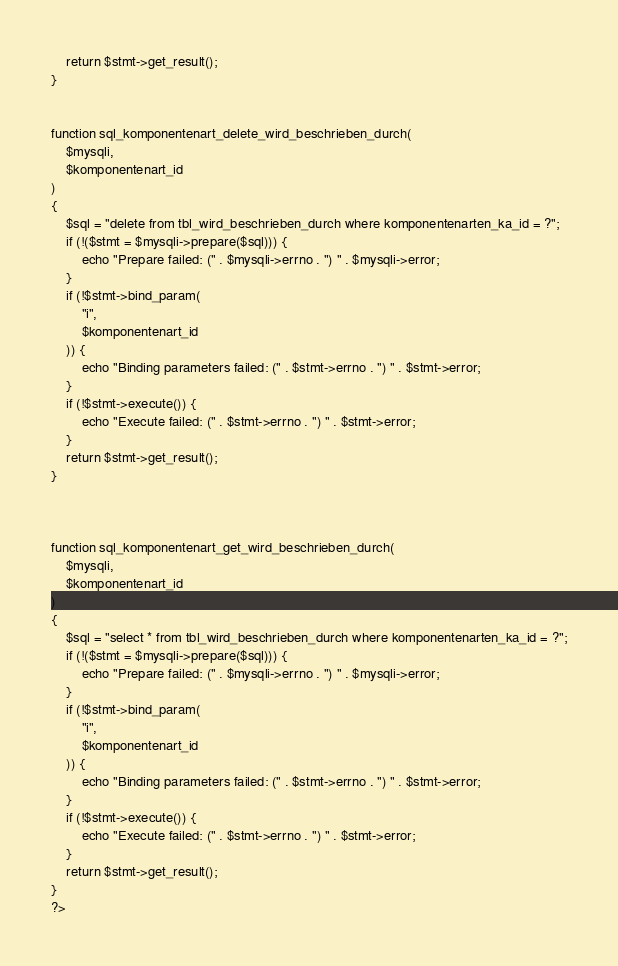Convert code to text. <code><loc_0><loc_0><loc_500><loc_500><_PHP_>    return $stmt->get_result();
}


function sql_komponentenart_delete_wird_beschrieben_durch(
    $mysqli,
    $komponentenart_id
)
{
    $sql = "delete from tbl_wird_beschrieben_durch where komponentenarten_ka_id = ?";
    if (!($stmt = $mysqli->prepare($sql))) {
        echo "Prepare failed: (" . $mysqli->errno . ") " . $mysqli->error;
    }
    if (!$stmt->bind_param(
        "i",
        $komponentenart_id
    )) {
        echo "Binding parameters failed: (" . $stmt->errno . ") " . $stmt->error;
    }
    if (!$stmt->execute()) {
        echo "Execute failed: (" . $stmt->errno . ") " . $stmt->error;
    }
    return $stmt->get_result();
}



function sql_komponentenart_get_wird_beschrieben_durch(
    $mysqli,
    $komponentenart_id
)
{
    $sql = "select * from tbl_wird_beschrieben_durch where komponentenarten_ka_id = ?";
    if (!($stmt = $mysqli->prepare($sql))) {
        echo "Prepare failed: (" . $mysqli->errno . ") " . $mysqli->error;
    }
    if (!$stmt->bind_param(
        "i",
        $komponentenart_id
    )) {
        echo "Binding parameters failed: (" . $stmt->errno . ") " . $stmt->error;
    }
    if (!$stmt->execute()) {
        echo "Execute failed: (" . $stmt->errno . ") " . $stmt->error;
    }
    return $stmt->get_result();
}
?>

</code> 